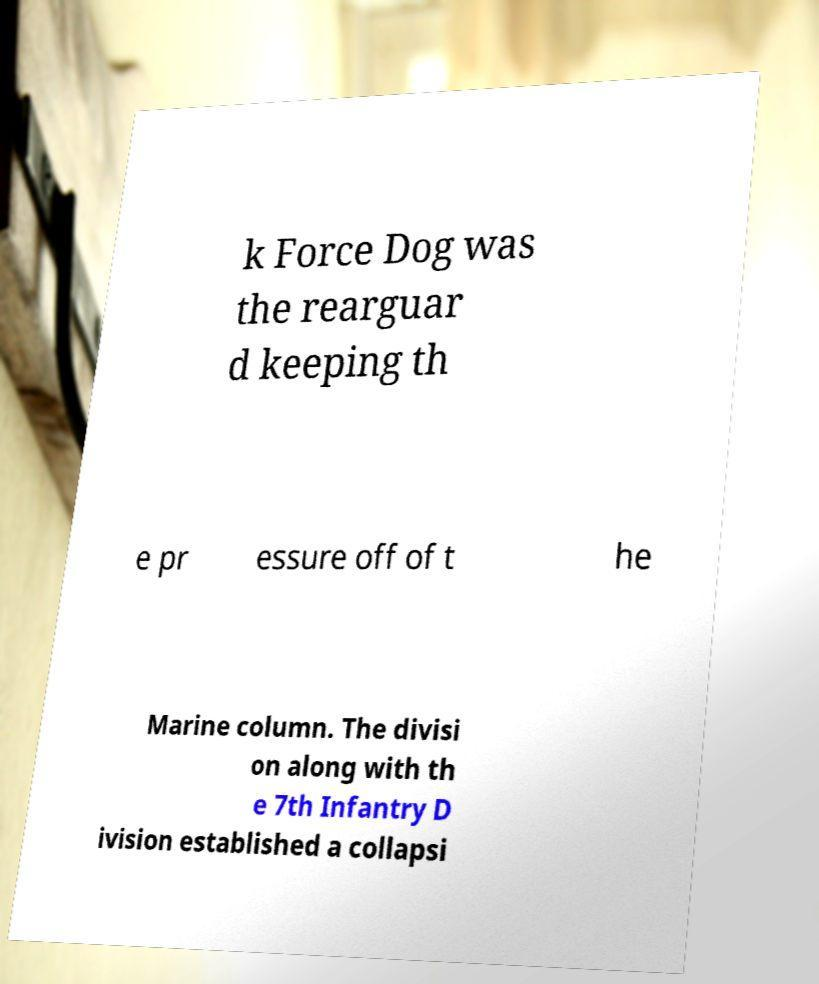Could you extract and type out the text from this image? k Force Dog was the rearguar d keeping th e pr essure off of t he Marine column. The divisi on along with th e 7th Infantry D ivision established a collapsi 